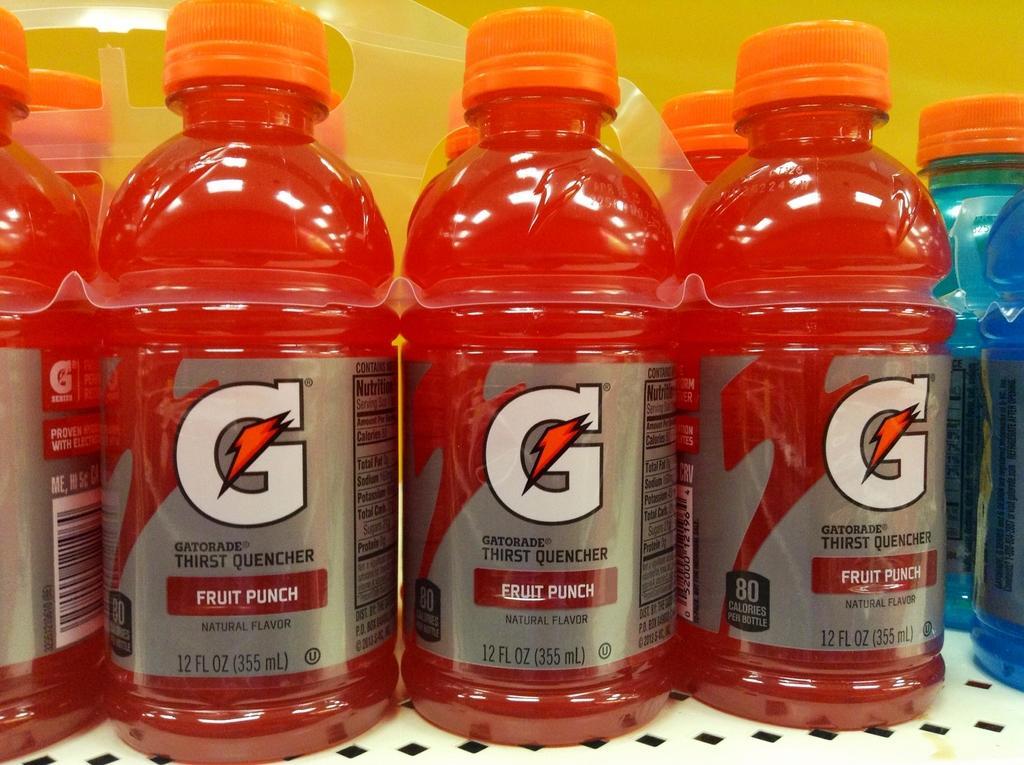In one or two sentences, can you explain what this image depicts? In the image we can see there are juice bottles which are of red colour. 